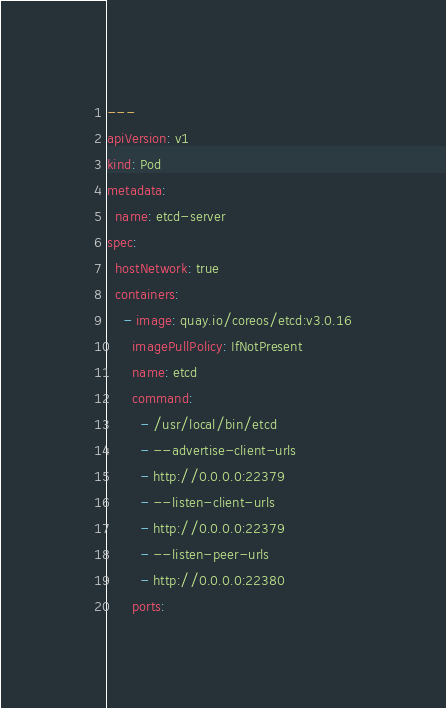<code> <loc_0><loc_0><loc_500><loc_500><_YAML_>---
apiVersion: v1
kind: Pod
metadata:
  name: etcd-server
spec:
  hostNetwork: true
  containers:
    - image: quay.io/coreos/etcd:v3.0.16
      imagePullPolicy: IfNotPresent
      name: etcd
      command:
        - /usr/local/bin/etcd
        - --advertise-client-urls
        - http://0.0.0.0:22379
        - --listen-client-urls
        - http://0.0.0.0:22379
        - --listen-peer-urls
        - http://0.0.0.0:22380
      ports:</code> 